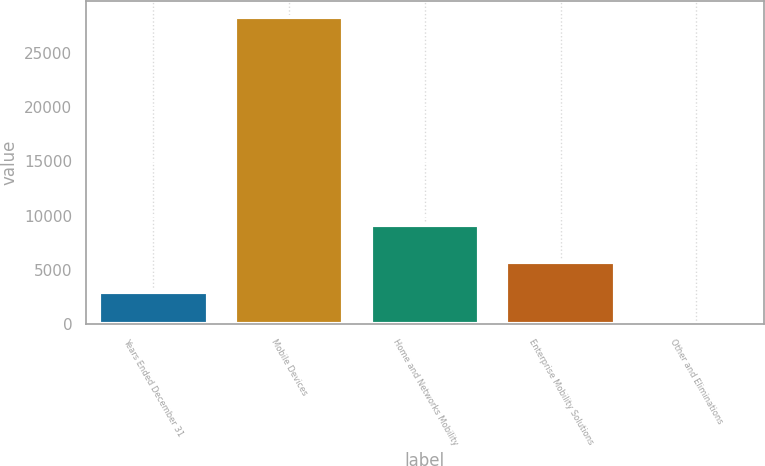Convert chart. <chart><loc_0><loc_0><loc_500><loc_500><bar_chart><fcel>Years Ended December 31<fcel>Mobile Devices<fcel>Home and Networks Mobility<fcel>Enterprise Mobility Solutions<fcel>Other and Eliminations<nl><fcel>2928.3<fcel>28383<fcel>9164<fcel>5756.6<fcel>100<nl></chart> 